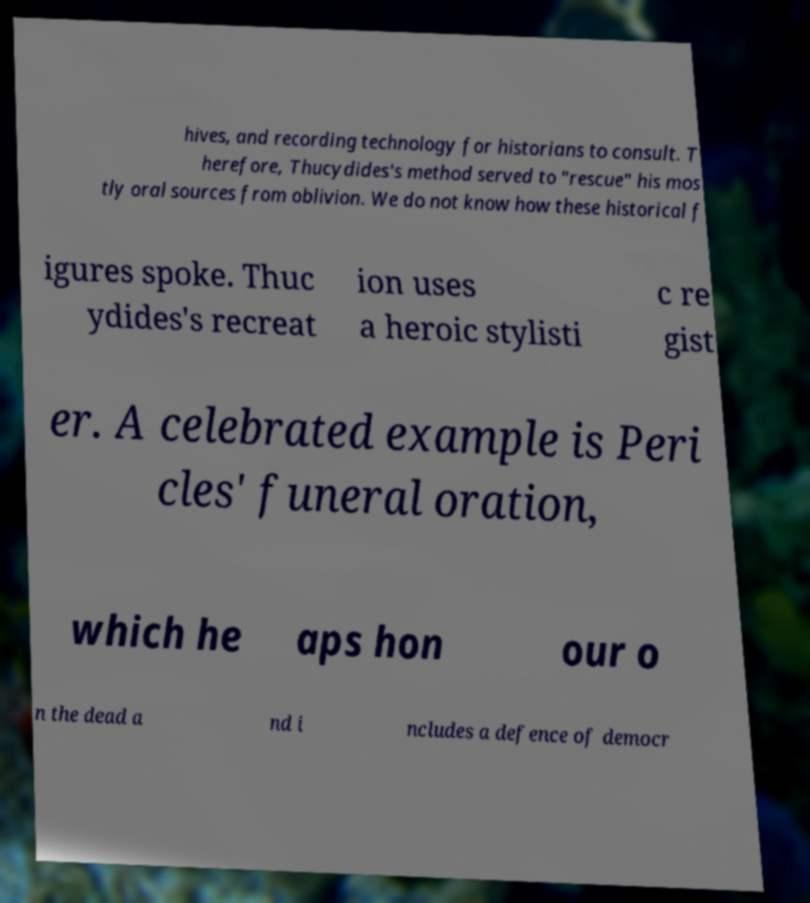What messages or text are displayed in this image? I need them in a readable, typed format. hives, and recording technology for historians to consult. T herefore, Thucydides's method served to "rescue" his mos tly oral sources from oblivion. We do not know how these historical f igures spoke. Thuc ydides's recreat ion uses a heroic stylisti c re gist er. A celebrated example is Peri cles' funeral oration, which he aps hon our o n the dead a nd i ncludes a defence of democr 